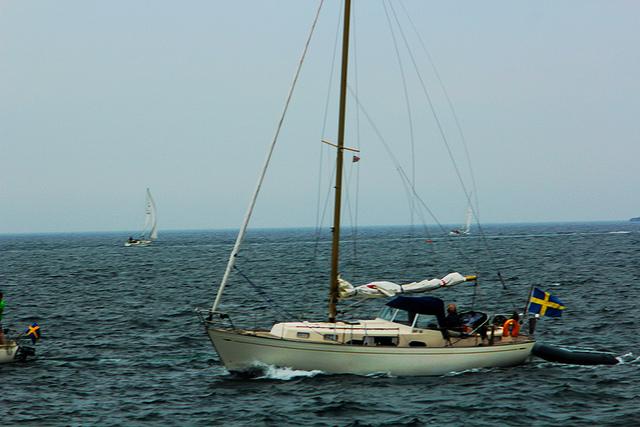What color is the boat in the foreground?
Short answer required. White. What color is the life jacket?
Short answer required. Orange. How tall are the waves?
Concise answer only. Short. What is the condition of the water?
Be succinct. Choppy. What nation's flag is flying on this boat?
Give a very brief answer. Sweden. Is the water calm?
Concise answer only. No. 